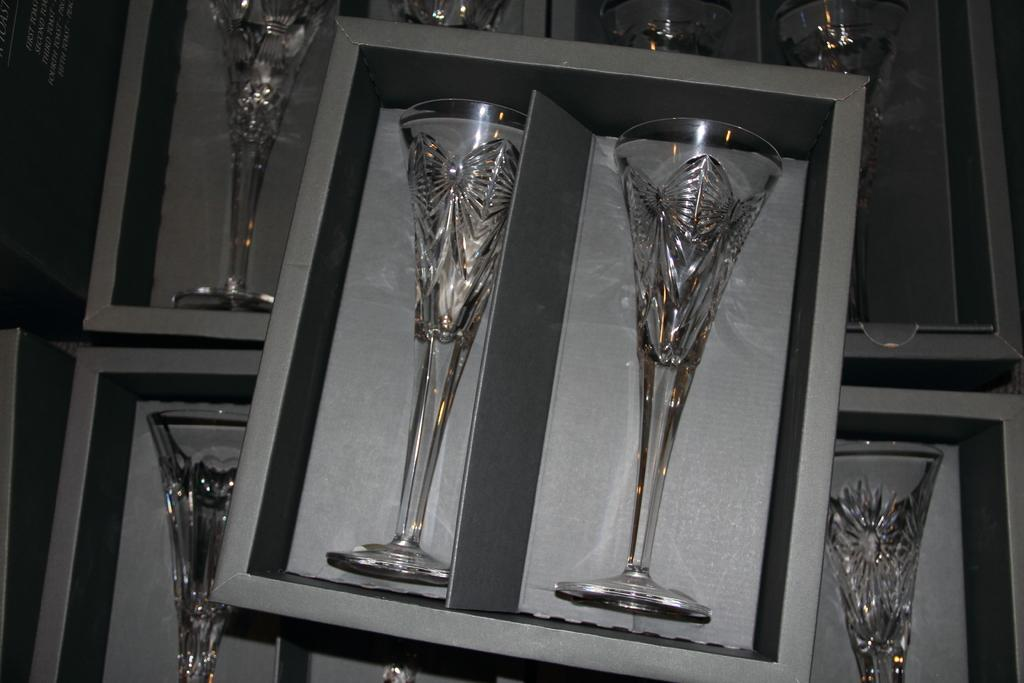What objects are in the image? There are glasses in the image. How are the glasses arranged in the image? The glasses are placed in boxes. Where are the boxes located in the image? The boxes are in the middle of the image. What color are the boxes? The boxes are grey in color. What type of pot is being used by the laborer in the image? There is no laborer or pot present in the image. Can you describe the home where the glasses are located in the image? The image does not provide information about the home where the glasses are located. 